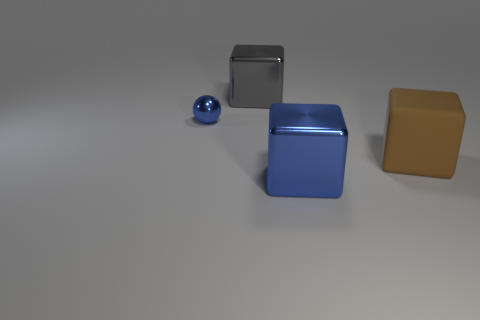What shape is the object that is the same color as the sphere?
Your answer should be compact. Cube. The thing that is the same color as the small metallic ball is what size?
Make the answer very short. Large. There is a large object that is behind the big blue object and in front of the small blue thing; what shape is it?
Your answer should be compact. Cube. There is a gray shiny thing; are there any big rubber cubes behind it?
Your answer should be very brief. No. What is the size of the other rubber object that is the same shape as the big blue object?
Offer a terse response. Large. Are there any other things that are the same size as the gray block?
Provide a short and direct response. Yes. Does the tiny blue metal thing have the same shape as the big gray object?
Keep it short and to the point. No. What size is the blue sphere that is left of the big thing in front of the large matte block?
Offer a terse response. Small. There is a rubber object that is the same shape as the large gray metallic thing; what is its color?
Make the answer very short. Brown. What number of other small spheres are the same color as the tiny ball?
Give a very brief answer. 0. 